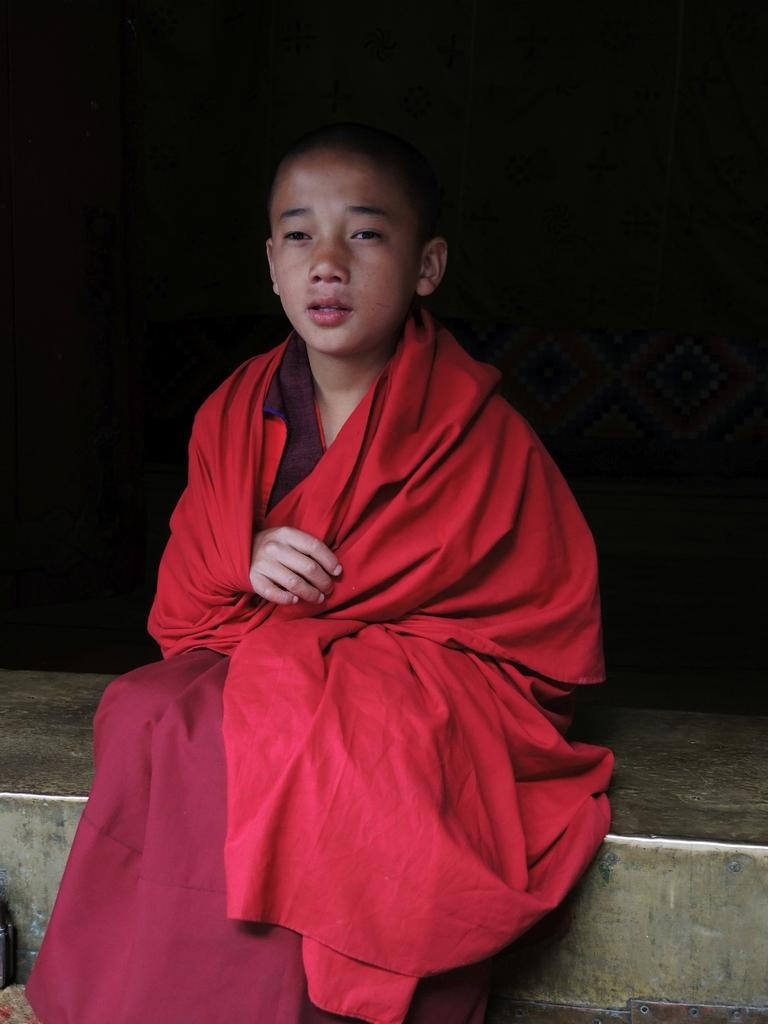What is the position of the person in the image? There is a person sitting on the floor in the image. What can be observed about the lighting in the image? The background of the image is dark. What type of company does the person have in the image? There is no company present in the image; it only shows a person sitting on the floor with a dark background. 